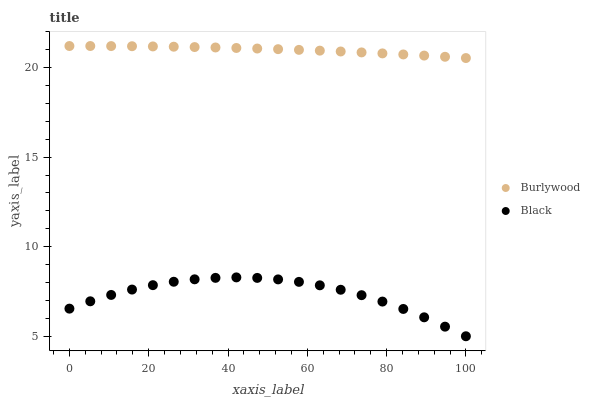Does Black have the minimum area under the curve?
Answer yes or no. Yes. Does Burlywood have the maximum area under the curve?
Answer yes or no. Yes. Does Black have the maximum area under the curve?
Answer yes or no. No. Is Burlywood the smoothest?
Answer yes or no. Yes. Is Black the roughest?
Answer yes or no. Yes. Is Black the smoothest?
Answer yes or no. No. Does Black have the lowest value?
Answer yes or no. Yes. Does Burlywood have the highest value?
Answer yes or no. Yes. Does Black have the highest value?
Answer yes or no. No. Is Black less than Burlywood?
Answer yes or no. Yes. Is Burlywood greater than Black?
Answer yes or no. Yes. Does Black intersect Burlywood?
Answer yes or no. No. 